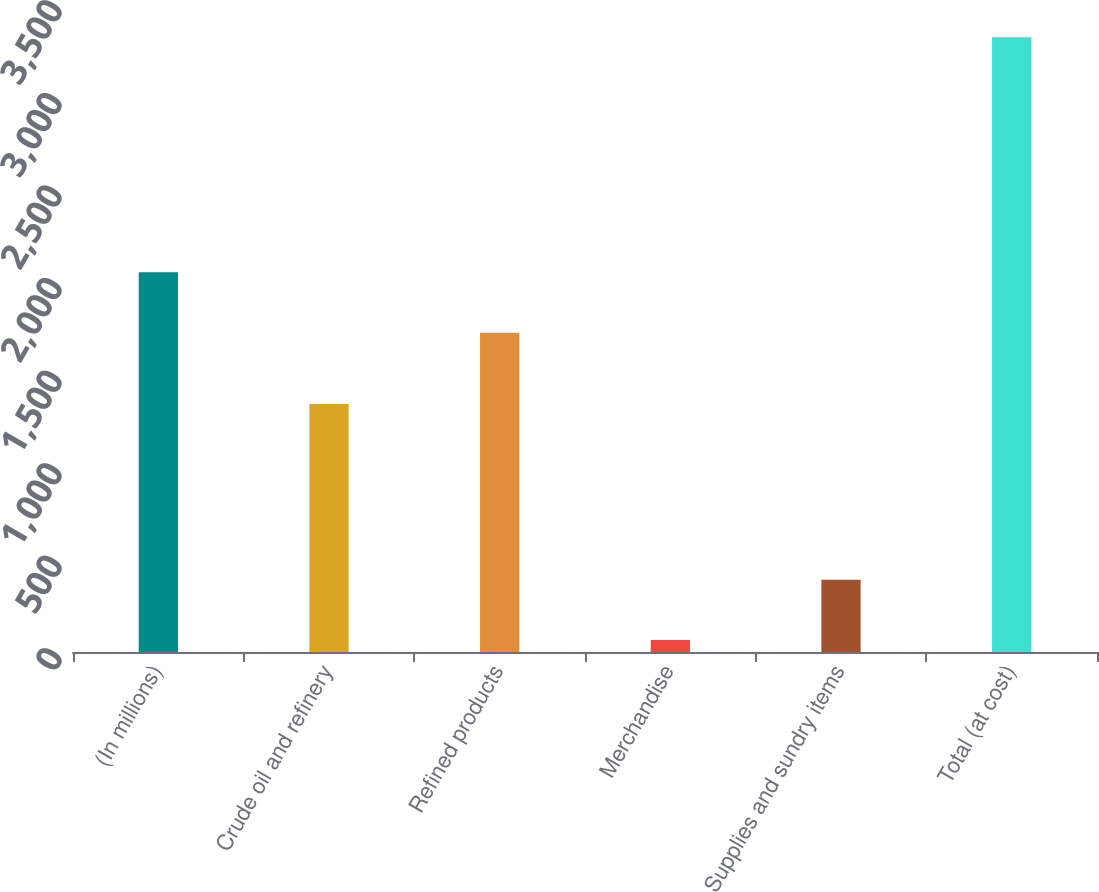Convert chart. <chart><loc_0><loc_0><loc_500><loc_500><bar_chart><fcel>(In millions)<fcel>Crude oil and refinery<fcel>Refined products<fcel>Merchandise<fcel>Supplies and sundry items<fcel>Total (at cost)<nl><fcel>2050.5<fcel>1339<fcel>1725<fcel>65<fcel>390.5<fcel>3320<nl></chart> 